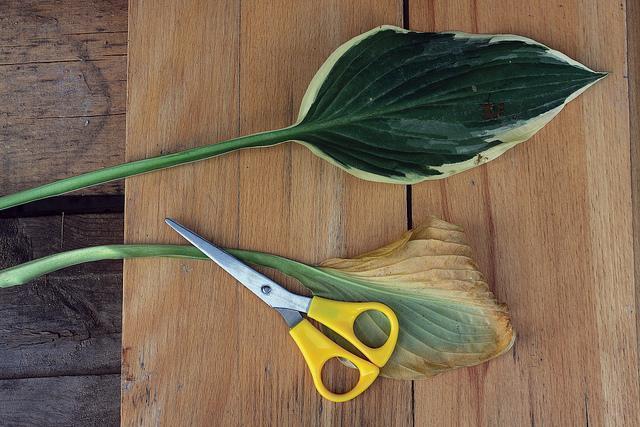How many people are wearing white shirt?
Give a very brief answer. 0. 